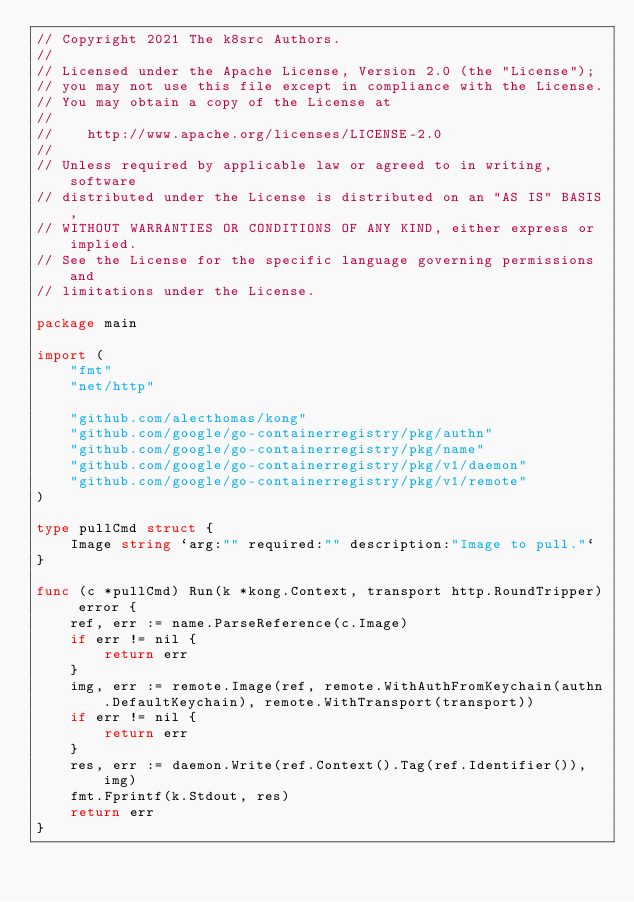Convert code to text. <code><loc_0><loc_0><loc_500><loc_500><_Go_>// Copyright 2021 The k8src Authors.
//
// Licensed under the Apache License, Version 2.0 (the "License");
// you may not use this file except in compliance with the License.
// You may obtain a copy of the License at
//
//    http://www.apache.org/licenses/LICENSE-2.0
//
// Unless required by applicable law or agreed to in writing, software
// distributed under the License is distributed on an "AS IS" BASIS,
// WITHOUT WARRANTIES OR CONDITIONS OF ANY KIND, either express or implied.
// See the License for the specific language governing permissions and
// limitations under the License.

package main

import (
	"fmt"
	"net/http"

	"github.com/alecthomas/kong"
	"github.com/google/go-containerregistry/pkg/authn"
	"github.com/google/go-containerregistry/pkg/name"
	"github.com/google/go-containerregistry/pkg/v1/daemon"
	"github.com/google/go-containerregistry/pkg/v1/remote"
)

type pullCmd struct {
	Image string `arg:"" required:"" description:"Image to pull."`
}

func (c *pullCmd) Run(k *kong.Context, transport http.RoundTripper) error {
	ref, err := name.ParseReference(c.Image)
	if err != nil {
		return err
	}
	img, err := remote.Image(ref, remote.WithAuthFromKeychain(authn.DefaultKeychain), remote.WithTransport(transport))
	if err != nil {
		return err
	}
	res, err := daemon.Write(ref.Context().Tag(ref.Identifier()), img)
	fmt.Fprintf(k.Stdout, res)
	return err
}
</code> 